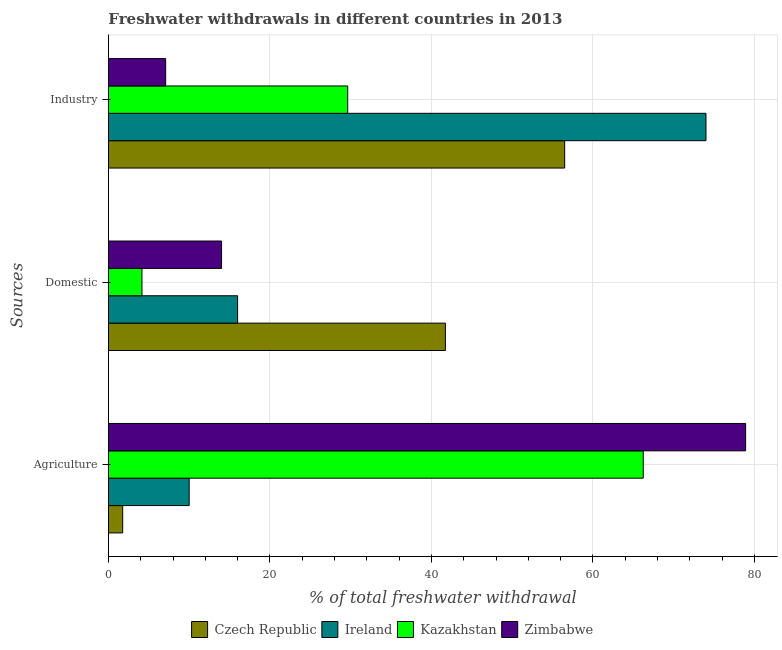How many groups of bars are there?
Provide a succinct answer. 3. Are the number of bars per tick equal to the number of legend labels?
Your response must be concise. Yes. Are the number of bars on each tick of the Y-axis equal?
Offer a very short reply. Yes. How many bars are there on the 3rd tick from the top?
Your response must be concise. 4. What is the label of the 1st group of bars from the top?
Your response must be concise. Industry. What is the percentage of freshwater withdrawal for agriculture in Zimbabwe?
Provide a succinct answer. 78.91. Across all countries, what is the maximum percentage of freshwater withdrawal for agriculture?
Your response must be concise. 78.91. Across all countries, what is the minimum percentage of freshwater withdrawal for agriculture?
Ensure brevity in your answer.  1.77. In which country was the percentage of freshwater withdrawal for domestic purposes maximum?
Offer a terse response. Czech Republic. In which country was the percentage of freshwater withdrawal for industry minimum?
Your answer should be compact. Zimbabwe. What is the total percentage of freshwater withdrawal for industry in the graph?
Offer a very short reply. 167.22. What is the difference between the percentage of freshwater withdrawal for domestic purposes in Ireland and that in Zimbabwe?
Give a very brief answer. 1.99. What is the difference between the percentage of freshwater withdrawal for agriculture in Kazakhstan and the percentage of freshwater withdrawal for domestic purposes in Ireland?
Keep it short and to the point. 50.23. What is the average percentage of freshwater withdrawal for industry per country?
Your answer should be very brief. 41.8. What is the difference between the percentage of freshwater withdrawal for agriculture and percentage of freshwater withdrawal for domestic purposes in Ireland?
Ensure brevity in your answer.  -6. What is the ratio of the percentage of freshwater withdrawal for industry in Kazakhstan to that in Zimbabwe?
Offer a terse response. 4.18. Is the difference between the percentage of freshwater withdrawal for agriculture in Czech Republic and Kazakhstan greater than the difference between the percentage of freshwater withdrawal for industry in Czech Republic and Kazakhstan?
Your answer should be compact. No. What is the difference between the highest and the second highest percentage of freshwater withdrawal for industry?
Make the answer very short. 17.5. What is the difference between the highest and the lowest percentage of freshwater withdrawal for agriculture?
Your response must be concise. 77.14. What does the 1st bar from the top in Industry represents?
Keep it short and to the point. Zimbabwe. What does the 1st bar from the bottom in Domestic represents?
Offer a terse response. Czech Republic. How many bars are there?
Provide a short and direct response. 12. Does the graph contain any zero values?
Offer a terse response. No. How are the legend labels stacked?
Your answer should be compact. Horizontal. What is the title of the graph?
Your response must be concise. Freshwater withdrawals in different countries in 2013. What is the label or title of the X-axis?
Provide a succinct answer. % of total freshwater withdrawal. What is the label or title of the Y-axis?
Ensure brevity in your answer.  Sources. What is the % of total freshwater withdrawal in Czech Republic in Agriculture?
Provide a short and direct response. 1.77. What is the % of total freshwater withdrawal of Kazakhstan in Agriculture?
Give a very brief answer. 66.23. What is the % of total freshwater withdrawal in Zimbabwe in Agriculture?
Give a very brief answer. 78.91. What is the % of total freshwater withdrawal of Czech Republic in Domestic?
Offer a very short reply. 41.73. What is the % of total freshwater withdrawal of Ireland in Domestic?
Offer a terse response. 16. What is the % of total freshwater withdrawal of Kazakhstan in Domestic?
Offer a very short reply. 4.15. What is the % of total freshwater withdrawal of Zimbabwe in Domestic?
Your answer should be very brief. 14.01. What is the % of total freshwater withdrawal in Czech Republic in Industry?
Give a very brief answer. 56.5. What is the % of total freshwater withdrawal in Ireland in Industry?
Keep it short and to the point. 74. What is the % of total freshwater withdrawal of Kazakhstan in Industry?
Offer a terse response. 29.63. What is the % of total freshwater withdrawal in Zimbabwe in Industry?
Make the answer very short. 7.09. Across all Sources, what is the maximum % of total freshwater withdrawal of Czech Republic?
Offer a terse response. 56.5. Across all Sources, what is the maximum % of total freshwater withdrawal in Kazakhstan?
Offer a very short reply. 66.23. Across all Sources, what is the maximum % of total freshwater withdrawal in Zimbabwe?
Make the answer very short. 78.91. Across all Sources, what is the minimum % of total freshwater withdrawal in Czech Republic?
Provide a short and direct response. 1.77. Across all Sources, what is the minimum % of total freshwater withdrawal in Ireland?
Your response must be concise. 10. Across all Sources, what is the minimum % of total freshwater withdrawal of Kazakhstan?
Make the answer very short. 4.15. Across all Sources, what is the minimum % of total freshwater withdrawal in Zimbabwe?
Offer a very short reply. 7.09. What is the total % of total freshwater withdrawal of Czech Republic in the graph?
Give a very brief answer. 100. What is the total % of total freshwater withdrawal of Ireland in the graph?
Provide a short and direct response. 100. What is the total % of total freshwater withdrawal in Kazakhstan in the graph?
Provide a succinct answer. 100.01. What is the total % of total freshwater withdrawal of Zimbabwe in the graph?
Offer a very short reply. 100.01. What is the difference between the % of total freshwater withdrawal in Czech Republic in Agriculture and that in Domestic?
Make the answer very short. -39.96. What is the difference between the % of total freshwater withdrawal in Kazakhstan in Agriculture and that in Domestic?
Your answer should be very brief. 62.08. What is the difference between the % of total freshwater withdrawal of Zimbabwe in Agriculture and that in Domestic?
Give a very brief answer. 64.9. What is the difference between the % of total freshwater withdrawal in Czech Republic in Agriculture and that in Industry?
Your answer should be very brief. -54.73. What is the difference between the % of total freshwater withdrawal of Ireland in Agriculture and that in Industry?
Give a very brief answer. -64. What is the difference between the % of total freshwater withdrawal of Kazakhstan in Agriculture and that in Industry?
Your response must be concise. 36.6. What is the difference between the % of total freshwater withdrawal in Zimbabwe in Agriculture and that in Industry?
Give a very brief answer. 71.82. What is the difference between the % of total freshwater withdrawal of Czech Republic in Domestic and that in Industry?
Your answer should be very brief. -14.77. What is the difference between the % of total freshwater withdrawal of Ireland in Domestic and that in Industry?
Provide a short and direct response. -58. What is the difference between the % of total freshwater withdrawal of Kazakhstan in Domestic and that in Industry?
Your answer should be very brief. -25.48. What is the difference between the % of total freshwater withdrawal of Zimbabwe in Domestic and that in Industry?
Provide a short and direct response. 6.92. What is the difference between the % of total freshwater withdrawal in Czech Republic in Agriculture and the % of total freshwater withdrawal in Ireland in Domestic?
Offer a terse response. -14.23. What is the difference between the % of total freshwater withdrawal of Czech Republic in Agriculture and the % of total freshwater withdrawal of Kazakhstan in Domestic?
Provide a short and direct response. -2.39. What is the difference between the % of total freshwater withdrawal in Czech Republic in Agriculture and the % of total freshwater withdrawal in Zimbabwe in Domestic?
Offer a terse response. -12.24. What is the difference between the % of total freshwater withdrawal in Ireland in Agriculture and the % of total freshwater withdrawal in Kazakhstan in Domestic?
Keep it short and to the point. 5.85. What is the difference between the % of total freshwater withdrawal in Ireland in Agriculture and the % of total freshwater withdrawal in Zimbabwe in Domestic?
Make the answer very short. -4.01. What is the difference between the % of total freshwater withdrawal in Kazakhstan in Agriculture and the % of total freshwater withdrawal in Zimbabwe in Domestic?
Offer a terse response. 52.22. What is the difference between the % of total freshwater withdrawal of Czech Republic in Agriculture and the % of total freshwater withdrawal of Ireland in Industry?
Provide a succinct answer. -72.23. What is the difference between the % of total freshwater withdrawal of Czech Republic in Agriculture and the % of total freshwater withdrawal of Kazakhstan in Industry?
Ensure brevity in your answer.  -27.86. What is the difference between the % of total freshwater withdrawal of Czech Republic in Agriculture and the % of total freshwater withdrawal of Zimbabwe in Industry?
Offer a very short reply. -5.32. What is the difference between the % of total freshwater withdrawal in Ireland in Agriculture and the % of total freshwater withdrawal in Kazakhstan in Industry?
Make the answer very short. -19.63. What is the difference between the % of total freshwater withdrawal of Ireland in Agriculture and the % of total freshwater withdrawal of Zimbabwe in Industry?
Keep it short and to the point. 2.91. What is the difference between the % of total freshwater withdrawal of Kazakhstan in Agriculture and the % of total freshwater withdrawal of Zimbabwe in Industry?
Make the answer very short. 59.14. What is the difference between the % of total freshwater withdrawal in Czech Republic in Domestic and the % of total freshwater withdrawal in Ireland in Industry?
Your response must be concise. -32.27. What is the difference between the % of total freshwater withdrawal of Czech Republic in Domestic and the % of total freshwater withdrawal of Zimbabwe in Industry?
Your answer should be compact. 34.64. What is the difference between the % of total freshwater withdrawal in Ireland in Domestic and the % of total freshwater withdrawal in Kazakhstan in Industry?
Keep it short and to the point. -13.63. What is the difference between the % of total freshwater withdrawal in Ireland in Domestic and the % of total freshwater withdrawal in Zimbabwe in Industry?
Make the answer very short. 8.91. What is the difference between the % of total freshwater withdrawal in Kazakhstan in Domestic and the % of total freshwater withdrawal in Zimbabwe in Industry?
Your answer should be compact. -2.93. What is the average % of total freshwater withdrawal in Czech Republic per Sources?
Your answer should be compact. 33.33. What is the average % of total freshwater withdrawal of Ireland per Sources?
Your response must be concise. 33.33. What is the average % of total freshwater withdrawal in Kazakhstan per Sources?
Your answer should be compact. 33.34. What is the average % of total freshwater withdrawal in Zimbabwe per Sources?
Offer a very short reply. 33.34. What is the difference between the % of total freshwater withdrawal of Czech Republic and % of total freshwater withdrawal of Ireland in Agriculture?
Keep it short and to the point. -8.23. What is the difference between the % of total freshwater withdrawal in Czech Republic and % of total freshwater withdrawal in Kazakhstan in Agriculture?
Provide a succinct answer. -64.46. What is the difference between the % of total freshwater withdrawal of Czech Republic and % of total freshwater withdrawal of Zimbabwe in Agriculture?
Your response must be concise. -77.14. What is the difference between the % of total freshwater withdrawal of Ireland and % of total freshwater withdrawal of Kazakhstan in Agriculture?
Your answer should be compact. -56.23. What is the difference between the % of total freshwater withdrawal of Ireland and % of total freshwater withdrawal of Zimbabwe in Agriculture?
Provide a succinct answer. -68.91. What is the difference between the % of total freshwater withdrawal in Kazakhstan and % of total freshwater withdrawal in Zimbabwe in Agriculture?
Provide a succinct answer. -12.68. What is the difference between the % of total freshwater withdrawal in Czech Republic and % of total freshwater withdrawal in Ireland in Domestic?
Make the answer very short. 25.73. What is the difference between the % of total freshwater withdrawal in Czech Republic and % of total freshwater withdrawal in Kazakhstan in Domestic?
Provide a short and direct response. 37.58. What is the difference between the % of total freshwater withdrawal of Czech Republic and % of total freshwater withdrawal of Zimbabwe in Domestic?
Make the answer very short. 27.72. What is the difference between the % of total freshwater withdrawal in Ireland and % of total freshwater withdrawal in Kazakhstan in Domestic?
Keep it short and to the point. 11.85. What is the difference between the % of total freshwater withdrawal in Ireland and % of total freshwater withdrawal in Zimbabwe in Domestic?
Give a very brief answer. 1.99. What is the difference between the % of total freshwater withdrawal in Kazakhstan and % of total freshwater withdrawal in Zimbabwe in Domestic?
Offer a very short reply. -9.86. What is the difference between the % of total freshwater withdrawal of Czech Republic and % of total freshwater withdrawal of Ireland in Industry?
Offer a very short reply. -17.5. What is the difference between the % of total freshwater withdrawal of Czech Republic and % of total freshwater withdrawal of Kazakhstan in Industry?
Keep it short and to the point. 26.87. What is the difference between the % of total freshwater withdrawal of Czech Republic and % of total freshwater withdrawal of Zimbabwe in Industry?
Offer a terse response. 49.41. What is the difference between the % of total freshwater withdrawal of Ireland and % of total freshwater withdrawal of Kazakhstan in Industry?
Your response must be concise. 44.37. What is the difference between the % of total freshwater withdrawal in Ireland and % of total freshwater withdrawal in Zimbabwe in Industry?
Make the answer very short. 66.91. What is the difference between the % of total freshwater withdrawal of Kazakhstan and % of total freshwater withdrawal of Zimbabwe in Industry?
Your response must be concise. 22.54. What is the ratio of the % of total freshwater withdrawal in Czech Republic in Agriculture to that in Domestic?
Keep it short and to the point. 0.04. What is the ratio of the % of total freshwater withdrawal of Ireland in Agriculture to that in Domestic?
Offer a terse response. 0.62. What is the ratio of the % of total freshwater withdrawal of Kazakhstan in Agriculture to that in Domestic?
Give a very brief answer. 15.95. What is the ratio of the % of total freshwater withdrawal of Zimbabwe in Agriculture to that in Domestic?
Make the answer very short. 5.63. What is the ratio of the % of total freshwater withdrawal of Czech Republic in Agriculture to that in Industry?
Ensure brevity in your answer.  0.03. What is the ratio of the % of total freshwater withdrawal in Ireland in Agriculture to that in Industry?
Your answer should be very brief. 0.14. What is the ratio of the % of total freshwater withdrawal in Kazakhstan in Agriculture to that in Industry?
Provide a short and direct response. 2.24. What is the ratio of the % of total freshwater withdrawal in Zimbabwe in Agriculture to that in Industry?
Your answer should be very brief. 11.13. What is the ratio of the % of total freshwater withdrawal of Czech Republic in Domestic to that in Industry?
Offer a very short reply. 0.74. What is the ratio of the % of total freshwater withdrawal in Ireland in Domestic to that in Industry?
Offer a terse response. 0.22. What is the ratio of the % of total freshwater withdrawal in Kazakhstan in Domestic to that in Industry?
Provide a short and direct response. 0.14. What is the ratio of the % of total freshwater withdrawal of Zimbabwe in Domestic to that in Industry?
Provide a succinct answer. 1.98. What is the difference between the highest and the second highest % of total freshwater withdrawal of Czech Republic?
Offer a very short reply. 14.77. What is the difference between the highest and the second highest % of total freshwater withdrawal of Ireland?
Your response must be concise. 58. What is the difference between the highest and the second highest % of total freshwater withdrawal of Kazakhstan?
Give a very brief answer. 36.6. What is the difference between the highest and the second highest % of total freshwater withdrawal of Zimbabwe?
Your answer should be compact. 64.9. What is the difference between the highest and the lowest % of total freshwater withdrawal of Czech Republic?
Ensure brevity in your answer.  54.73. What is the difference between the highest and the lowest % of total freshwater withdrawal of Kazakhstan?
Ensure brevity in your answer.  62.08. What is the difference between the highest and the lowest % of total freshwater withdrawal in Zimbabwe?
Provide a short and direct response. 71.82. 